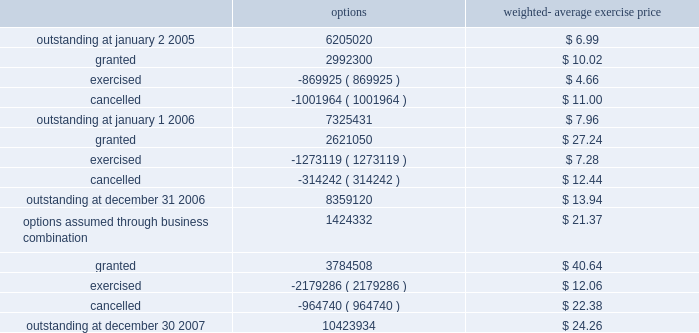Stock options 2005 stock and incentive plan in june 2005 , the stockholders of the company approved the 2005 stock and incentive plan ( the 2005 stock plan ) .
Upon adoption of the 2005 stock plan , issuance of options under the company 2019s existing 2000 stock plan ceased .
Additionally , in connection with the acquisition of solexa , the company assumed stock options granted under the 2005 solexa equity incentive plan ( the 2005 solexa equity plan ) .
As of december 30 , 2007 , an aggregate of up to 13485619 shares of the company 2019s common stock were reserved for issuance under the 2005 stock plan and the 2005 solexa equity plan .
The 2005 stock plan provides for an automatic annual increase in the shares reserved for issuance by the lesser of 5% ( 5 % ) of outstanding shares of the company 2019s common stock on the last day of the immediately preceding fiscal year , 1200000 shares or such lesser amount as determined by the company 2019s board of directors .
As of december 30 , 2007 , options to purchase 1834384 shares remained available for future grant under the 2005 stock plan and 2005 solexa equity plan .
The company 2019s stock option activity under all stock option plans from january 2 , 2005 through december 30 , 2007 is as follows : options weighted- average exercise price .
Illumina , inc .
Notes to consolidated financial statements 2014 ( continued ) .
What is the total value of granted options in 2006 , in millions? 
Computations: ((2621050 * 27.24) / 1000000)
Answer: 71.3974. 